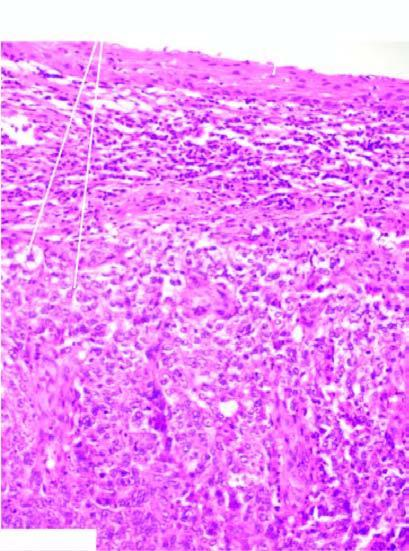s the tumour composed of undifferentiated anaplastic cells arranged in nests?
Answer the question using a single word or phrase. Yes 